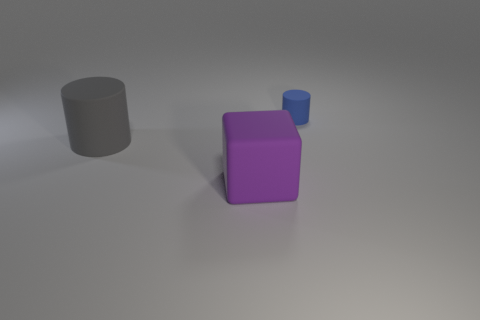Add 1 purple things. How many objects exist? 4 Subtract all blocks. How many objects are left? 2 Add 1 large rubber objects. How many large rubber objects are left? 3 Add 2 rubber blocks. How many rubber blocks exist? 3 Subtract 0 purple spheres. How many objects are left? 3 Subtract all blue objects. Subtract all purple blocks. How many objects are left? 1 